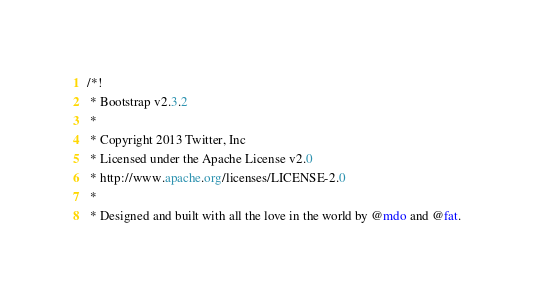Convert code to text. <code><loc_0><loc_0><loc_500><loc_500><_CSS_>/*!
 * Bootstrap v2.3.2
 *
 * Copyright 2013 Twitter, Inc
 * Licensed under the Apache License v2.0
 * http://www.apache.org/licenses/LICENSE-2.0
 *
 * Designed and built with all the love in the world by @mdo and @fat.</code> 